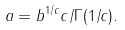<formula> <loc_0><loc_0><loc_500><loc_500>a = b ^ { 1 / c } c / \Gamma ( 1 / c ) .</formula> 